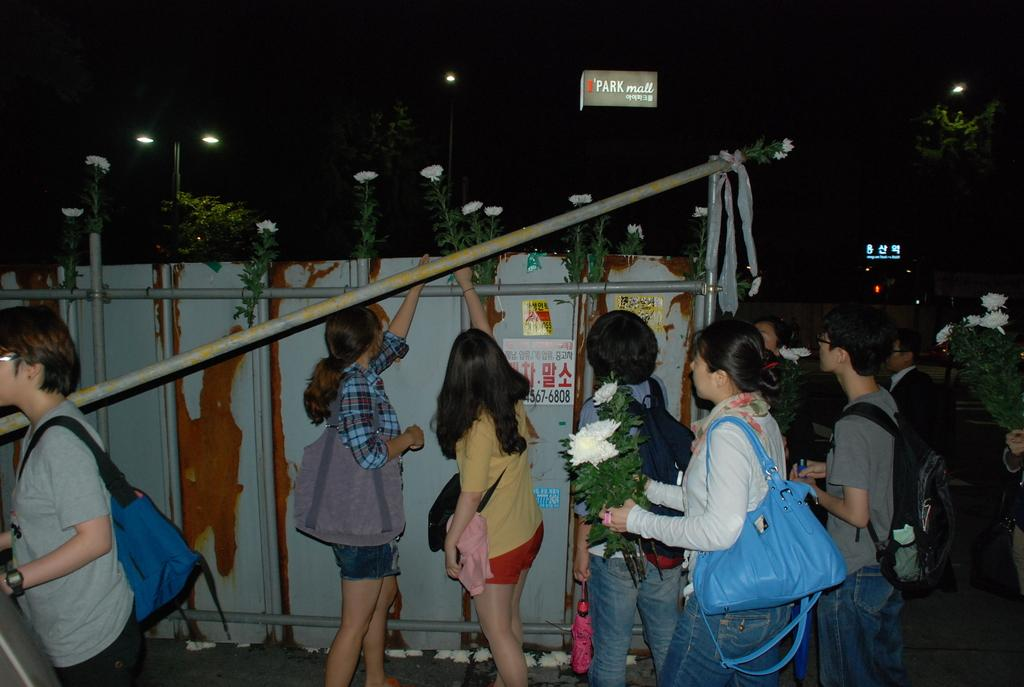What are the people in the image doing? There is a group of people standing on the road in the image. What items can be seen with the people? Bags are visible in the image. What type of vegetation is present in the image? Flowers are present in the image. What objects are used for support or display? Rods are visible in the image. What type of signage is present in the image? There is a poster in the image. What is being used for protection from the elements? An umbrella is present in the image. What type of signage indicates a specific location? There is a name board in the image. What can be seen providing illumination in the image? Lights are visible in the image. How would you describe the overall lighting in the image? The background of the image is dark. How many planes are flying in the image? There are no planes visible in the image. What fact can be determined about the image? The provided facts do not allow us to determine a specific fact about the image. 